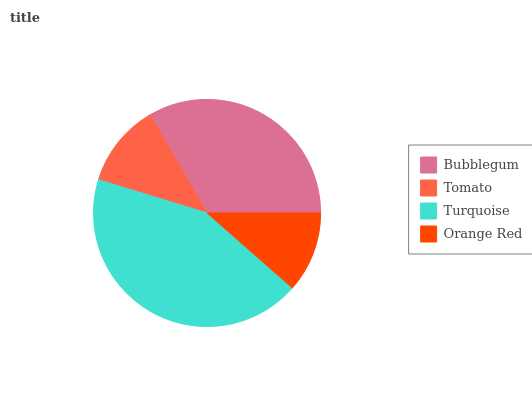Is Orange Red the minimum?
Answer yes or no. Yes. Is Turquoise the maximum?
Answer yes or no. Yes. Is Tomato the minimum?
Answer yes or no. No. Is Tomato the maximum?
Answer yes or no. No. Is Bubblegum greater than Tomato?
Answer yes or no. Yes. Is Tomato less than Bubblegum?
Answer yes or no. Yes. Is Tomato greater than Bubblegum?
Answer yes or no. No. Is Bubblegum less than Tomato?
Answer yes or no. No. Is Bubblegum the high median?
Answer yes or no. Yes. Is Tomato the low median?
Answer yes or no. Yes. Is Turquoise the high median?
Answer yes or no. No. Is Orange Red the low median?
Answer yes or no. No. 